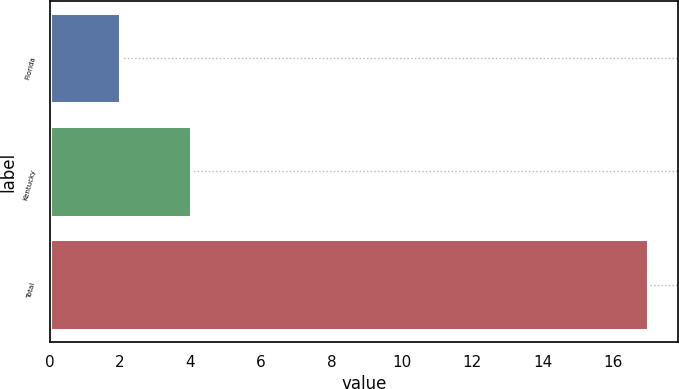Convert chart to OTSL. <chart><loc_0><loc_0><loc_500><loc_500><bar_chart><fcel>Florida<fcel>Kentucky<fcel>Total<nl><fcel>2<fcel>4<fcel>17<nl></chart> 